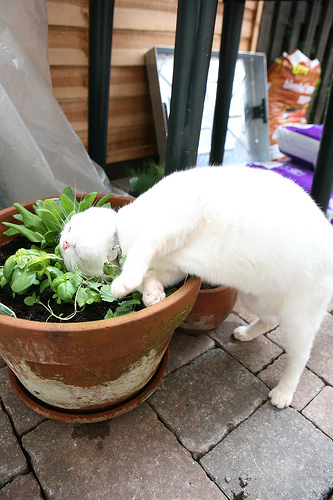Are there cats or birds that are not white? No, there are no cats or birds that are not white. 